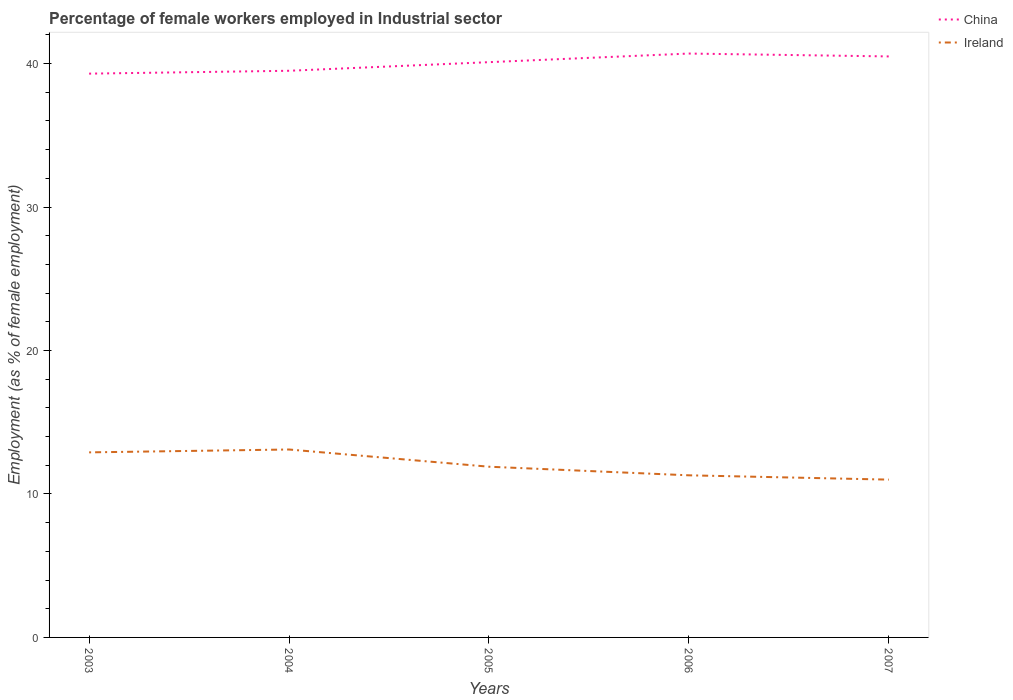Across all years, what is the maximum percentage of females employed in Industrial sector in China?
Provide a short and direct response. 39.3. What is the total percentage of females employed in Industrial sector in Ireland in the graph?
Ensure brevity in your answer.  2.1. What is the difference between the highest and the second highest percentage of females employed in Industrial sector in Ireland?
Keep it short and to the point. 2.1. What is the difference between the highest and the lowest percentage of females employed in Industrial sector in China?
Provide a succinct answer. 3. How many lines are there?
Make the answer very short. 2. What is the difference between two consecutive major ticks on the Y-axis?
Your response must be concise. 10. Does the graph contain grids?
Provide a succinct answer. No. Where does the legend appear in the graph?
Your answer should be very brief. Top right. What is the title of the graph?
Your answer should be compact. Percentage of female workers employed in Industrial sector. Does "Lebanon" appear as one of the legend labels in the graph?
Ensure brevity in your answer.  No. What is the label or title of the Y-axis?
Offer a terse response. Employment (as % of female employment). What is the Employment (as % of female employment) of China in 2003?
Make the answer very short. 39.3. What is the Employment (as % of female employment) in Ireland in 2003?
Keep it short and to the point. 12.9. What is the Employment (as % of female employment) in China in 2004?
Your response must be concise. 39.5. What is the Employment (as % of female employment) of Ireland in 2004?
Keep it short and to the point. 13.1. What is the Employment (as % of female employment) in China in 2005?
Your response must be concise. 40.1. What is the Employment (as % of female employment) in Ireland in 2005?
Make the answer very short. 11.9. What is the Employment (as % of female employment) in China in 2006?
Offer a very short reply. 40.7. What is the Employment (as % of female employment) in Ireland in 2006?
Make the answer very short. 11.3. What is the Employment (as % of female employment) in China in 2007?
Provide a short and direct response. 40.5. Across all years, what is the maximum Employment (as % of female employment) of China?
Your answer should be compact. 40.7. Across all years, what is the maximum Employment (as % of female employment) in Ireland?
Provide a short and direct response. 13.1. Across all years, what is the minimum Employment (as % of female employment) of China?
Offer a terse response. 39.3. Across all years, what is the minimum Employment (as % of female employment) of Ireland?
Provide a short and direct response. 11. What is the total Employment (as % of female employment) of China in the graph?
Make the answer very short. 200.1. What is the total Employment (as % of female employment) of Ireland in the graph?
Make the answer very short. 60.2. What is the difference between the Employment (as % of female employment) of Ireland in 2003 and that in 2004?
Offer a terse response. -0.2. What is the difference between the Employment (as % of female employment) in Ireland in 2003 and that in 2005?
Offer a terse response. 1. What is the difference between the Employment (as % of female employment) in Ireland in 2003 and that in 2006?
Your answer should be very brief. 1.6. What is the difference between the Employment (as % of female employment) in China in 2003 and that in 2007?
Your answer should be very brief. -1.2. What is the difference between the Employment (as % of female employment) of Ireland in 2004 and that in 2005?
Your response must be concise. 1.2. What is the difference between the Employment (as % of female employment) of China in 2004 and that in 2006?
Provide a short and direct response. -1.2. What is the difference between the Employment (as % of female employment) in China in 2004 and that in 2007?
Ensure brevity in your answer.  -1. What is the difference between the Employment (as % of female employment) in Ireland in 2005 and that in 2006?
Ensure brevity in your answer.  0.6. What is the difference between the Employment (as % of female employment) of Ireland in 2005 and that in 2007?
Offer a very short reply. 0.9. What is the difference between the Employment (as % of female employment) of China in 2006 and that in 2007?
Your answer should be compact. 0.2. What is the difference between the Employment (as % of female employment) of Ireland in 2006 and that in 2007?
Ensure brevity in your answer.  0.3. What is the difference between the Employment (as % of female employment) of China in 2003 and the Employment (as % of female employment) of Ireland in 2004?
Provide a succinct answer. 26.2. What is the difference between the Employment (as % of female employment) of China in 2003 and the Employment (as % of female employment) of Ireland in 2005?
Give a very brief answer. 27.4. What is the difference between the Employment (as % of female employment) in China in 2003 and the Employment (as % of female employment) in Ireland in 2007?
Keep it short and to the point. 28.3. What is the difference between the Employment (as % of female employment) in China in 2004 and the Employment (as % of female employment) in Ireland in 2005?
Ensure brevity in your answer.  27.6. What is the difference between the Employment (as % of female employment) in China in 2004 and the Employment (as % of female employment) in Ireland in 2006?
Your response must be concise. 28.2. What is the difference between the Employment (as % of female employment) of China in 2004 and the Employment (as % of female employment) of Ireland in 2007?
Your answer should be compact. 28.5. What is the difference between the Employment (as % of female employment) of China in 2005 and the Employment (as % of female employment) of Ireland in 2006?
Your answer should be compact. 28.8. What is the difference between the Employment (as % of female employment) of China in 2005 and the Employment (as % of female employment) of Ireland in 2007?
Offer a terse response. 29.1. What is the difference between the Employment (as % of female employment) in China in 2006 and the Employment (as % of female employment) in Ireland in 2007?
Offer a terse response. 29.7. What is the average Employment (as % of female employment) of China per year?
Make the answer very short. 40.02. What is the average Employment (as % of female employment) of Ireland per year?
Provide a short and direct response. 12.04. In the year 2003, what is the difference between the Employment (as % of female employment) of China and Employment (as % of female employment) of Ireland?
Your answer should be very brief. 26.4. In the year 2004, what is the difference between the Employment (as % of female employment) of China and Employment (as % of female employment) of Ireland?
Your answer should be compact. 26.4. In the year 2005, what is the difference between the Employment (as % of female employment) of China and Employment (as % of female employment) of Ireland?
Keep it short and to the point. 28.2. In the year 2006, what is the difference between the Employment (as % of female employment) in China and Employment (as % of female employment) in Ireland?
Keep it short and to the point. 29.4. In the year 2007, what is the difference between the Employment (as % of female employment) in China and Employment (as % of female employment) in Ireland?
Offer a very short reply. 29.5. What is the ratio of the Employment (as % of female employment) of China in 2003 to that in 2004?
Provide a succinct answer. 0.99. What is the ratio of the Employment (as % of female employment) of Ireland in 2003 to that in 2004?
Give a very brief answer. 0.98. What is the ratio of the Employment (as % of female employment) in Ireland in 2003 to that in 2005?
Make the answer very short. 1.08. What is the ratio of the Employment (as % of female employment) in China in 2003 to that in 2006?
Provide a short and direct response. 0.97. What is the ratio of the Employment (as % of female employment) of Ireland in 2003 to that in 2006?
Provide a short and direct response. 1.14. What is the ratio of the Employment (as % of female employment) in China in 2003 to that in 2007?
Offer a terse response. 0.97. What is the ratio of the Employment (as % of female employment) in Ireland in 2003 to that in 2007?
Provide a succinct answer. 1.17. What is the ratio of the Employment (as % of female employment) of China in 2004 to that in 2005?
Ensure brevity in your answer.  0.98. What is the ratio of the Employment (as % of female employment) of Ireland in 2004 to that in 2005?
Give a very brief answer. 1.1. What is the ratio of the Employment (as % of female employment) of China in 2004 to that in 2006?
Offer a terse response. 0.97. What is the ratio of the Employment (as % of female employment) in Ireland in 2004 to that in 2006?
Your response must be concise. 1.16. What is the ratio of the Employment (as % of female employment) of China in 2004 to that in 2007?
Your answer should be very brief. 0.98. What is the ratio of the Employment (as % of female employment) in Ireland in 2004 to that in 2007?
Provide a succinct answer. 1.19. What is the ratio of the Employment (as % of female employment) in China in 2005 to that in 2006?
Offer a very short reply. 0.99. What is the ratio of the Employment (as % of female employment) in Ireland in 2005 to that in 2006?
Keep it short and to the point. 1.05. What is the ratio of the Employment (as % of female employment) of Ireland in 2005 to that in 2007?
Give a very brief answer. 1.08. What is the ratio of the Employment (as % of female employment) of Ireland in 2006 to that in 2007?
Make the answer very short. 1.03. What is the difference between the highest and the second highest Employment (as % of female employment) of China?
Your answer should be very brief. 0.2. What is the difference between the highest and the lowest Employment (as % of female employment) in Ireland?
Keep it short and to the point. 2.1. 